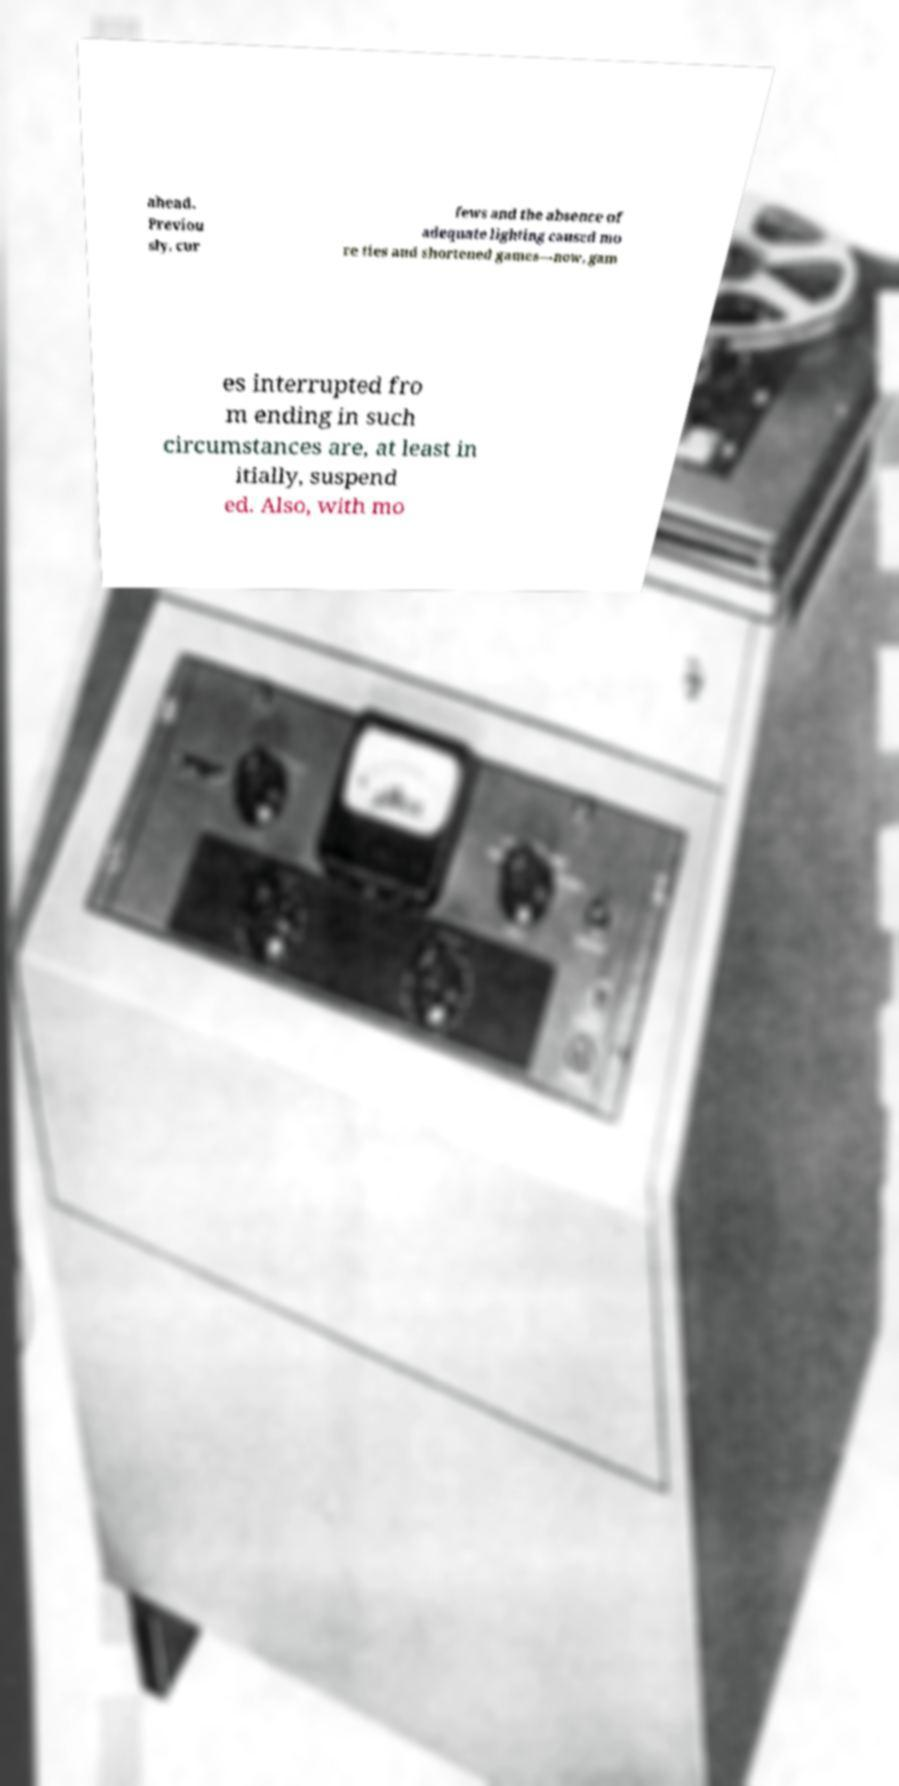What messages or text are displayed in this image? I need them in a readable, typed format. ahead. Previou sly, cur fews and the absence of adequate lighting caused mo re ties and shortened games—now, gam es interrupted fro m ending in such circumstances are, at least in itially, suspend ed. Also, with mo 